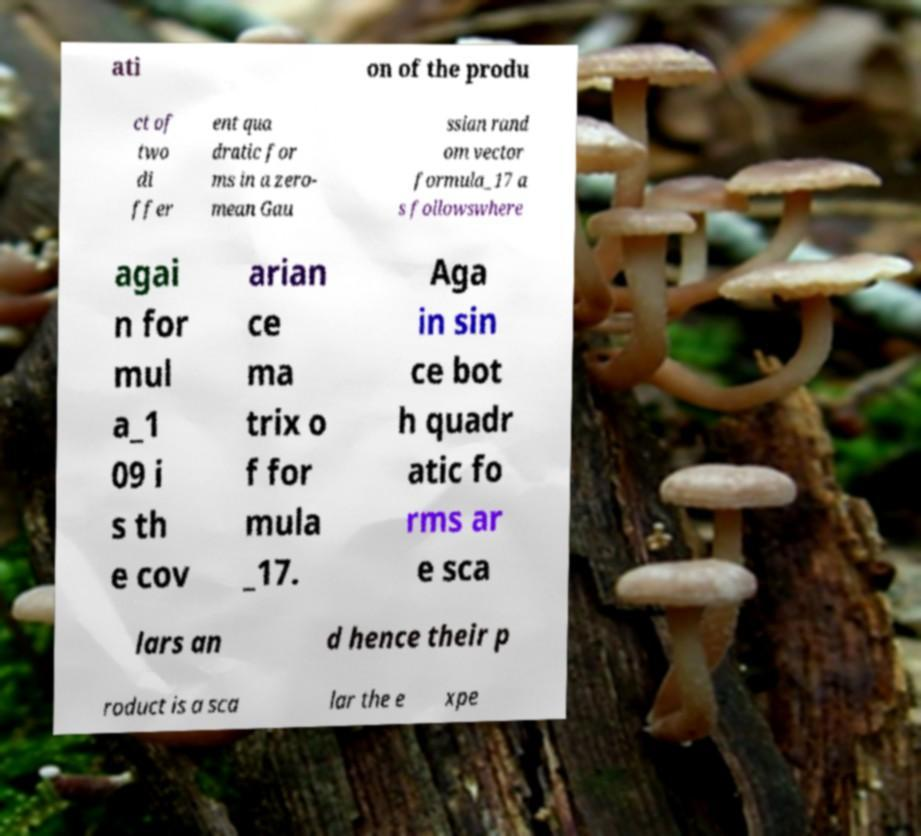Could you extract and type out the text from this image? ati on of the produ ct of two di ffer ent qua dratic for ms in a zero- mean Gau ssian rand om vector formula_17 a s followswhere agai n for mul a_1 09 i s th e cov arian ce ma trix o f for mula _17. Aga in sin ce bot h quadr atic fo rms ar e sca lars an d hence their p roduct is a sca lar the e xpe 